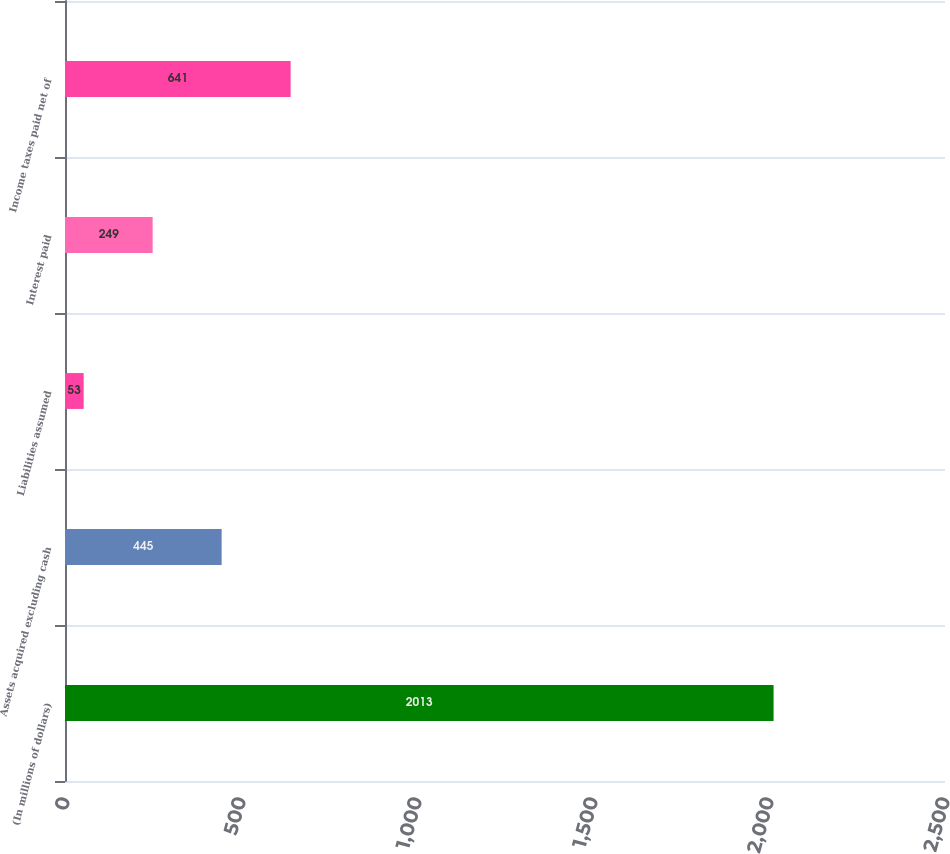Convert chart. <chart><loc_0><loc_0><loc_500><loc_500><bar_chart><fcel>(In millions of dollars)<fcel>Assets acquired excluding cash<fcel>Liabilities assumed<fcel>Interest paid<fcel>Income taxes paid net of<nl><fcel>2013<fcel>445<fcel>53<fcel>249<fcel>641<nl></chart> 